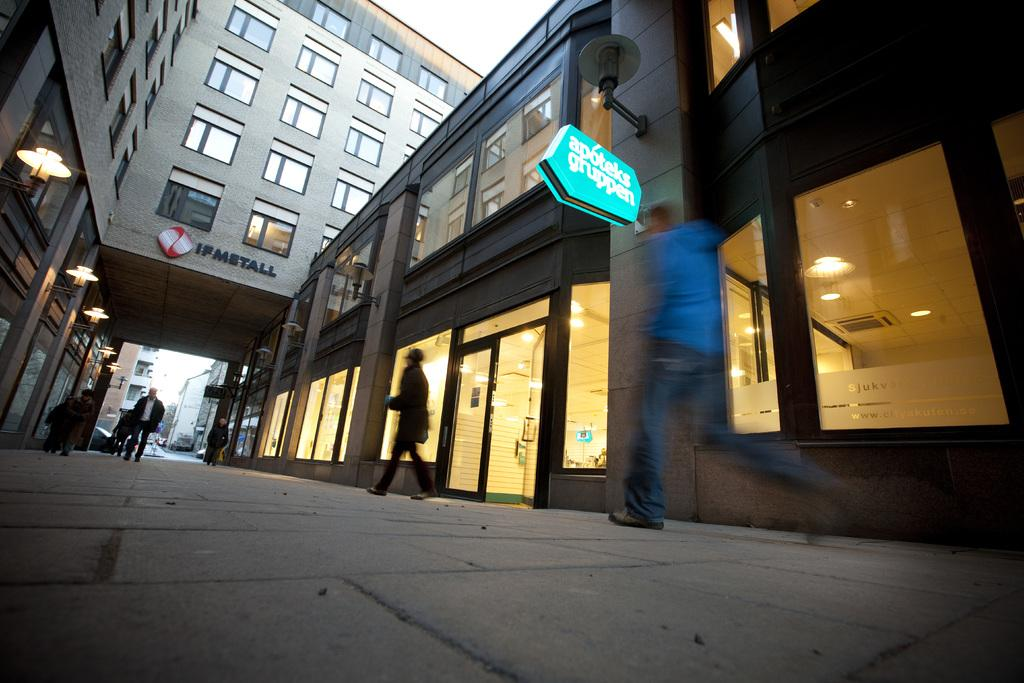What is the main subject of the image? The main subject of the image is people standing in the area. What can be seen in the background of the image? There are buildings in the area depicted in the image. What type of soda is being served on the sidewalk in the image? There is no soda or sidewalk present in the image; it only features people standing and buildings in the background. 